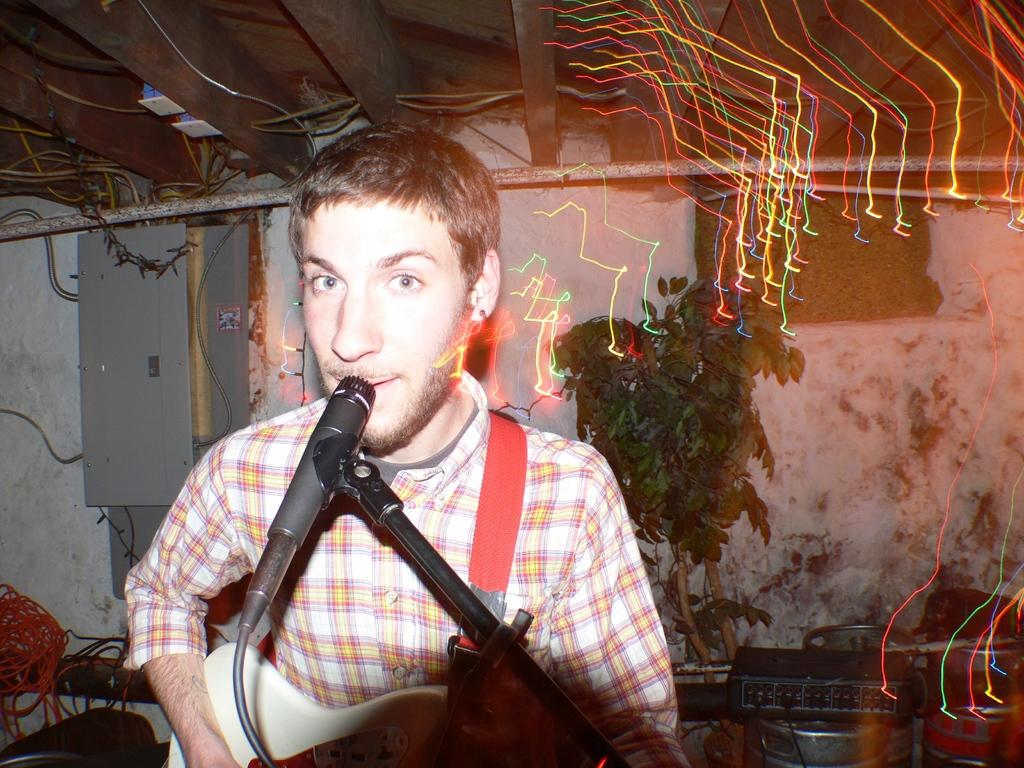What is the man in the image doing? The man is singing into a microphone and playing the guitar. Can you describe the setting in which the man is performing? There is a tree visible in the image, which suggests an outdoor setting. What type of pen is the man using to write lyrics in the image? There is no pen present in the image, as the man is singing and playing the guitar, not writing lyrics. 